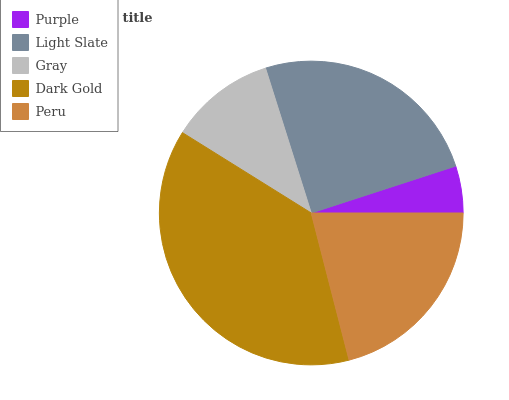Is Purple the minimum?
Answer yes or no. Yes. Is Dark Gold the maximum?
Answer yes or no. Yes. Is Light Slate the minimum?
Answer yes or no. No. Is Light Slate the maximum?
Answer yes or no. No. Is Light Slate greater than Purple?
Answer yes or no. Yes. Is Purple less than Light Slate?
Answer yes or no. Yes. Is Purple greater than Light Slate?
Answer yes or no. No. Is Light Slate less than Purple?
Answer yes or no. No. Is Peru the high median?
Answer yes or no. Yes. Is Peru the low median?
Answer yes or no. Yes. Is Gray the high median?
Answer yes or no. No. Is Gray the low median?
Answer yes or no. No. 